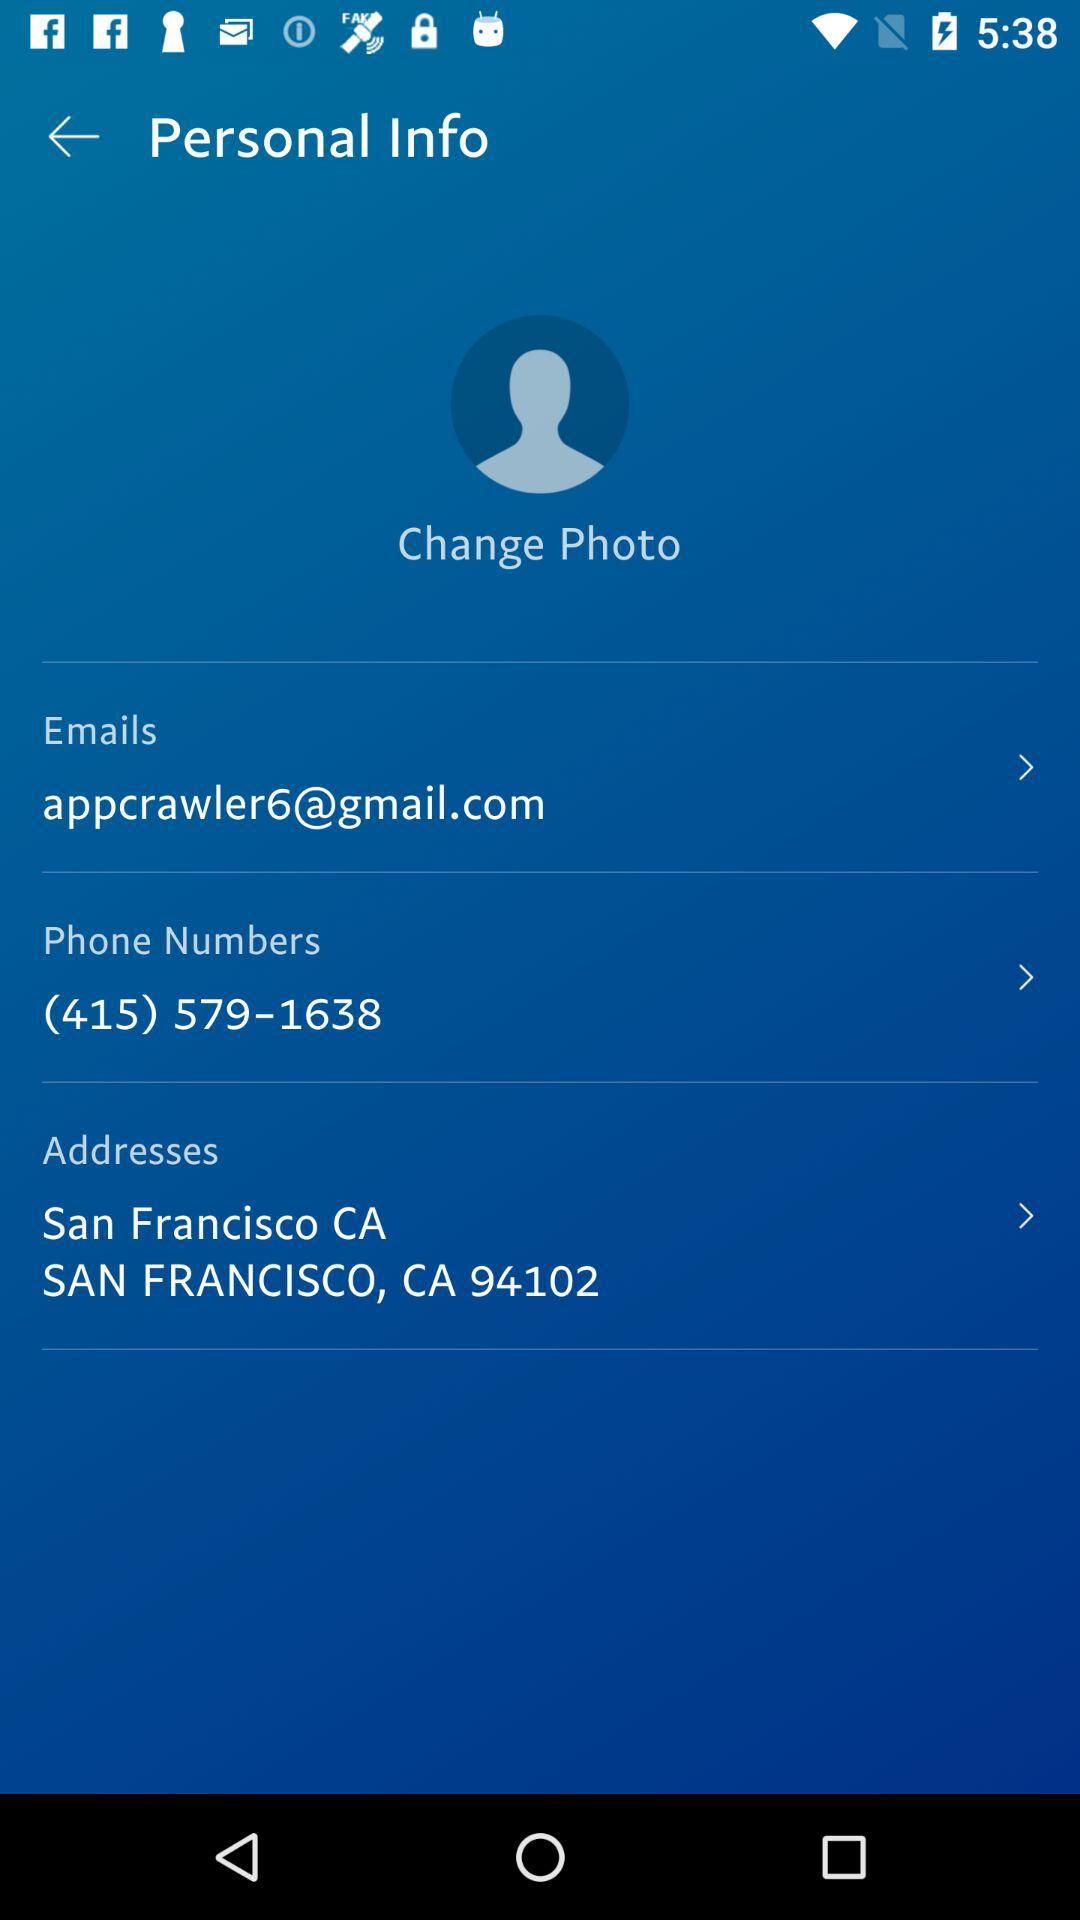What are the addresses mentioned there? The addresses mentioned are San Francisco, CA 94102. 